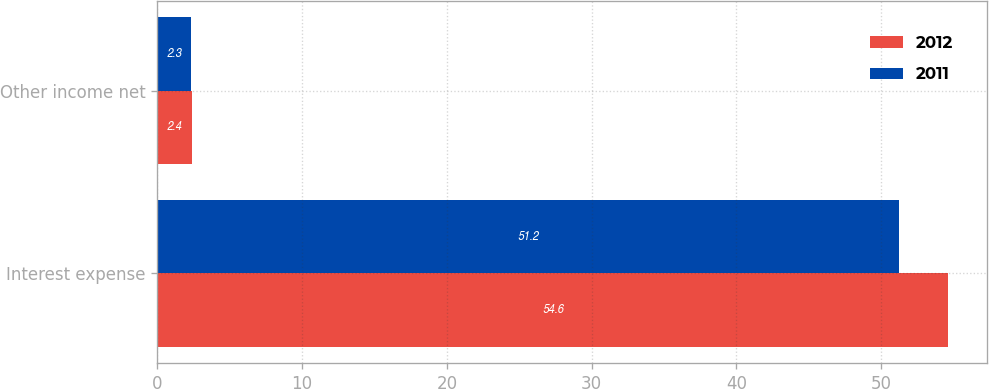Convert chart to OTSL. <chart><loc_0><loc_0><loc_500><loc_500><stacked_bar_chart><ecel><fcel>Interest expense<fcel>Other income net<nl><fcel>2012<fcel>54.6<fcel>2.4<nl><fcel>2011<fcel>51.2<fcel>2.3<nl></chart> 